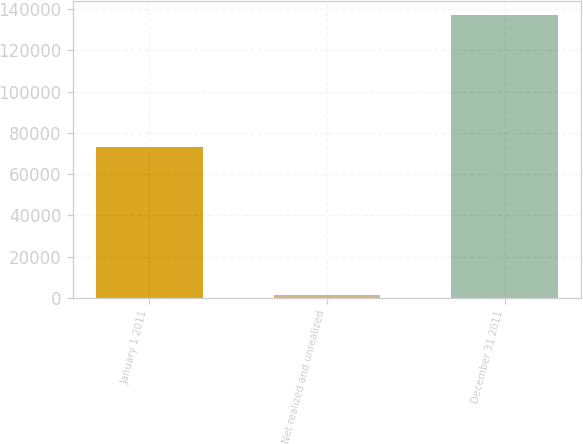Convert chart to OTSL. <chart><loc_0><loc_0><loc_500><loc_500><bar_chart><fcel>January 1 2011<fcel>Net realized and unrealized<fcel>December 31 2011<nl><fcel>73260<fcel>1199<fcel>137061<nl></chart> 